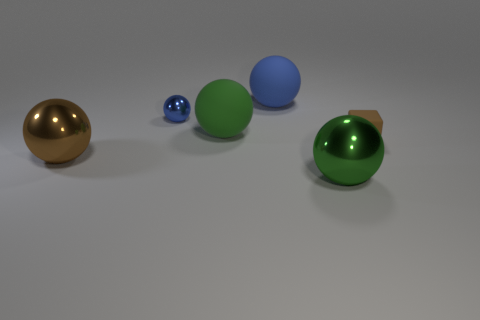Subtract all green spheres. How many were subtracted if there are1green spheres left? 1 Subtract all blue matte balls. How many balls are left? 4 Subtract all blocks. How many objects are left? 5 Subtract 4 balls. How many balls are left? 1 Subtract all cyan balls. Subtract all red cylinders. How many balls are left? 5 Subtract all gray blocks. How many red balls are left? 0 Subtract all blocks. Subtract all tiny balls. How many objects are left? 4 Add 5 green things. How many green things are left? 7 Add 1 brown metal spheres. How many brown metal spheres exist? 2 Add 4 brown spheres. How many objects exist? 10 